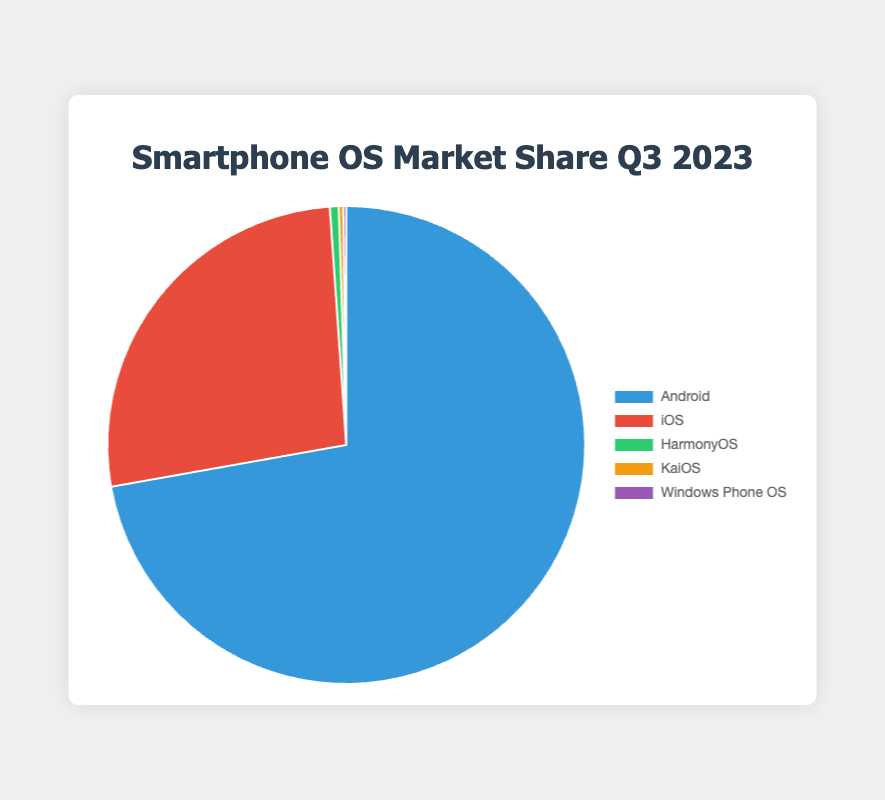Which operating system has the largest market share in Q3 2023? By looking at the pie chart, identify the segment with the largest portion. The biggest segment represents the operating system with the highest market share, which is Android.
Answer: Android What is the combined market share of HarmonyOS and KaiOS in Q3 2023? Add the market share percentages of HarmonyOS (0.6%) and KaiOS (0.3%) to find the combined market share. 0.6 + 0.3 = 0.9%.
Answer: 0.9% How much greater is iOS's market share compared to Windows Phone OS's market share in Q3 2023? Subtract Windows Phone OS's market share (0.2%) from iOS's market share (26.7%) to find the difference. 26.7 - 0.2 = 26.5%.
Answer: 26.5% Rank the operating systems by their market share from highest to lowest in Q3 2023. Reorder the market shares in descending order: Android (72.2%), iOS (26.7%), HarmonyOS (0.6%), KaiOS (0.3%), Windows Phone OS (0.2%).
Answer: Android, iOS, HarmonyOS, KaiOS, Windows Phone OS What percentage of the market share is held by operating systems other than Android and iOS in Q3 2023? Sum the market shares of HarmonyOS, KaiOS, and Windows Phone OS: 0.6% + 0.3% + 0.2% = 1.1%.
Answer: 1.1% If the market share of HarmonyOS doubled, what would its new percentage be? Multiply the existing market share of HarmonyOS (0.6%) by 2 to find the new percentage. 0.6 * 2 = 1.2%.
Answer: 1.2% What color is the segment representing iOS in the pie chart? By observing the chart's legend, you can see that the segment representing iOS is the second one listed and is colored red.
Answer: Red Which operating system has the smallest market share, and what is its percentage in Q3 2023? Identify the smallest segment in the pie chart, which corresponds to Windows Phone OS with a market share of 0.2%.
Answer: Windows Phone OS, 0.2% Consider Android and iOS together. What percentage of the total market share do they represent in Q3 2023? Add the market share percentages of Android (72.2%) and iOS (26.7%). 72.2 + 26.7 = 98.9%.
Answer: 98.9% 